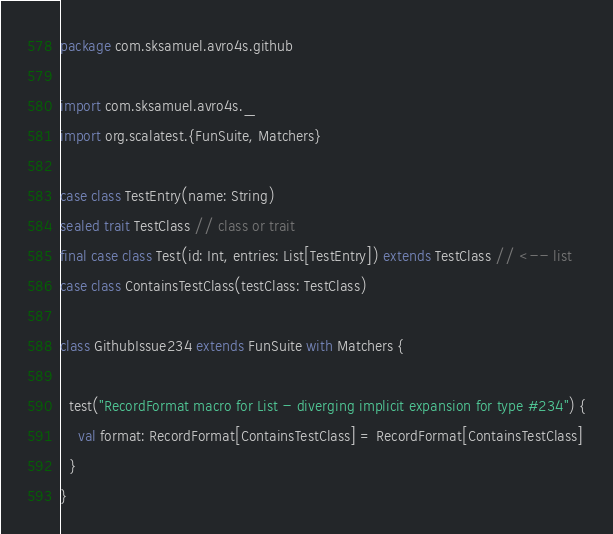<code> <loc_0><loc_0><loc_500><loc_500><_Scala_>package com.sksamuel.avro4s.github

import com.sksamuel.avro4s._
import org.scalatest.{FunSuite, Matchers}

case class TestEntry(name: String)
sealed trait TestClass // class or trait
final case class Test(id: Int, entries: List[TestEntry]) extends TestClass // <-- list
case class ContainsTestClass(testClass: TestClass)

class GithubIssue234 extends FunSuite with Matchers {

  test("RecordFormat macro for List - diverging implicit expansion for type #234") {
    val format: RecordFormat[ContainsTestClass] = RecordFormat[ContainsTestClass]
  }
}
</code> 